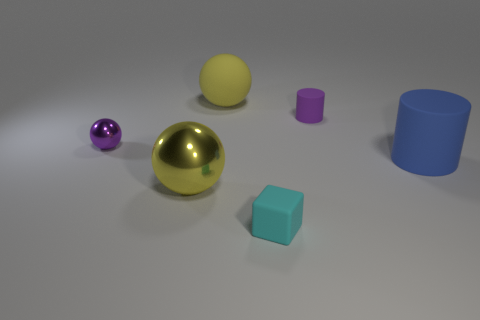Add 4 small purple rubber things. How many objects exist? 10 Subtract all cylinders. How many objects are left? 4 Subtract 0 blue balls. How many objects are left? 6 Subtract all small cyan objects. Subtract all big yellow objects. How many objects are left? 3 Add 6 balls. How many balls are left? 9 Add 6 small gray matte balls. How many small gray matte balls exist? 6 